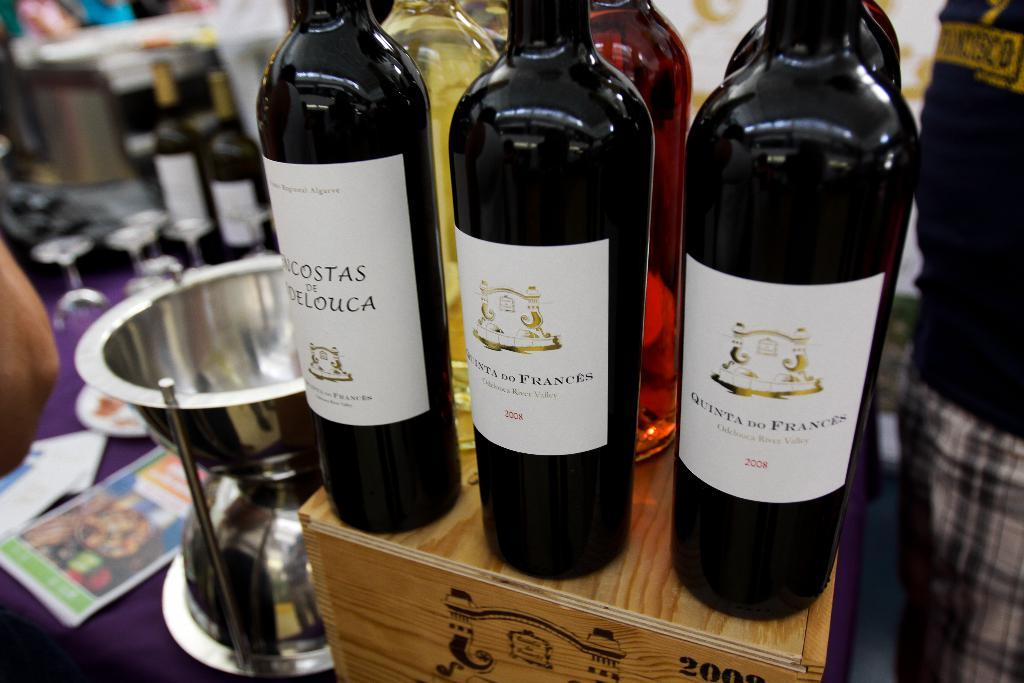What is placed on the wooden box in the image? There are wine bottles on a wooden box in the image. What is present on the table in the image? On the table, there are wine bottles, glasses, papers, and bowls. Can you describe any other objects on the table? There are other objects on the table, but their specific details are not mentioned in the provided facts. What type of story is being told by the cakes on the table? There are no cakes present in the image, so no story can be told by them. How many legs does the table have in the image? The number of legs on the table is not mentioned in the provided facts, so it cannot be determined from the image. 